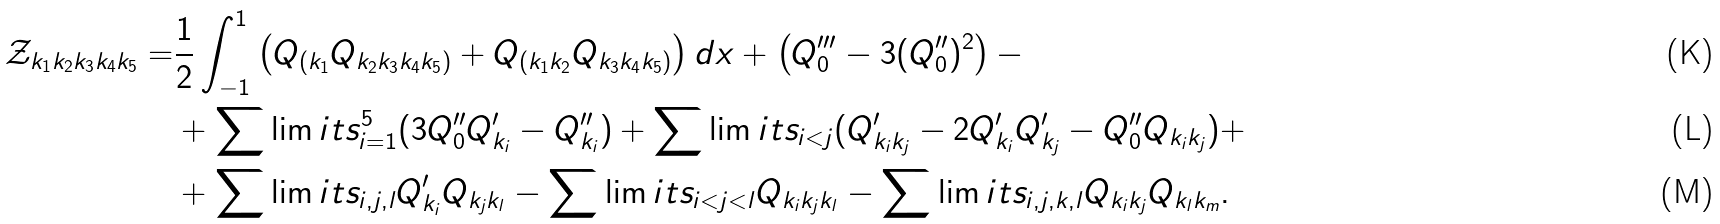<formula> <loc_0><loc_0><loc_500><loc_500>\mathcal { Z } _ { k _ { 1 } k _ { 2 } k _ { 3 } k _ { 4 } k _ { 5 } } = & \frac { 1 } { 2 } \int _ { - 1 } ^ { 1 } \left ( Q _ { ( k _ { 1 } } Q _ { k _ { 2 } k _ { 3 } k _ { 4 } k _ { 5 } ) } + Q _ { ( k _ { 1 } k _ { 2 } } Q _ { k _ { 3 } k _ { 4 } k _ { 5 } ) } \right ) d x + \left ( Q ^ { \prime \prime \prime } _ { 0 } - 3 ( Q ^ { \prime \prime } _ { 0 } ) ^ { 2 } \right ) - \\ & + \sum \lim i t s _ { i = 1 } ^ { 5 } ( 3 Q ^ { \prime \prime } _ { 0 } Q ^ { \prime } _ { k _ { i } } - Q ^ { \prime \prime } _ { k _ { i } } ) + \sum \lim i t s _ { i < j } ( Q ^ { \prime } _ { k _ { i } k _ { j } } - 2 Q ^ { \prime } _ { k _ { i } } Q ^ { \prime } _ { k _ { j } } - Q ^ { \prime \prime } _ { 0 } Q _ { k _ { i } k _ { j } } ) + \\ & + \sum \lim i t s _ { i , j , l } Q ^ { \prime } _ { k _ { i } } Q _ { k _ { j } k _ { l } } - \sum \lim i t s _ { i < j < l } Q _ { k _ { i } k _ { j } k _ { l } } - \sum \lim i t s _ { i , j , k , l } Q _ { k _ { i } k _ { j } } Q _ { k _ { l } k _ { m } } .</formula> 